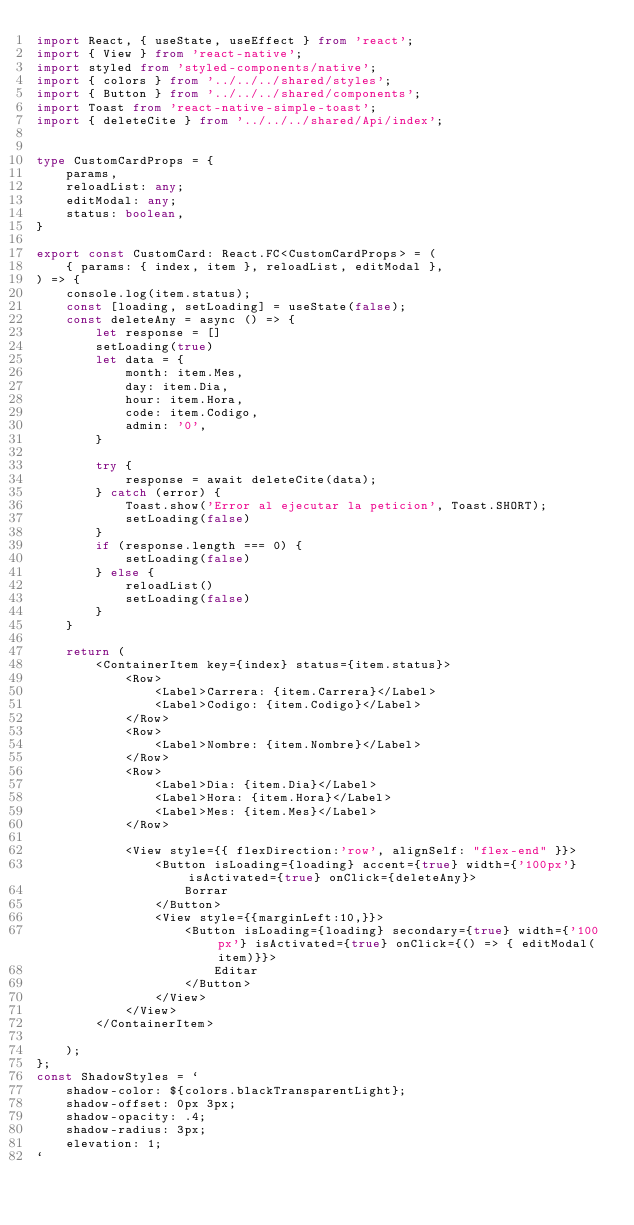Convert code to text. <code><loc_0><loc_0><loc_500><loc_500><_TypeScript_>import React, { useState, useEffect } from 'react';
import { View } from 'react-native';
import styled from 'styled-components/native';
import { colors } from '../../../shared/styles';
import { Button } from '../../../shared/components';
import Toast from 'react-native-simple-toast';
import { deleteCite } from '../../../shared/Api/index';


type CustomCardProps = {
    params,
    reloadList: any;
    editModal: any;
    status: boolean,
}

export const CustomCard: React.FC<CustomCardProps> = (
    { params: { index, item }, reloadList, editModal }, 
) => { 
    console.log(item.status);
    const [loading, setLoading] = useState(false);
    const deleteAny = async () => {
        let response = []
        setLoading(true)
        let data = {
            month: item.Mes,
            day: item.Dia,
            hour: item.Hora,
            code: item.Codigo,
            admin: '0',
        }
        
        try {
            response = await deleteCite(data);
        } catch (error) {
            Toast.show('Error al ejecutar la peticion', Toast.SHORT);
            setLoading(false)
        }
        if (response.length === 0) {
            setLoading(false)
        } else {
            reloadList()
            setLoading(false)
        }
    }
    
    return (
        <ContainerItem key={index} status={item.status}>
            <Row>
                <Label>Carrera: {item.Carrera}</Label>
                <Label>Codigo: {item.Codigo}</Label>
            </Row>
            <Row>
                <Label>Nombre: {item.Nombre}</Label>
            </Row>
            <Row>
                <Label>Dia: {item.Dia}</Label>
                <Label>Hora: {item.Hora}</Label>
                <Label>Mes: {item.Mes}</Label>
            </Row>

            <View style={{ flexDirection:'row', alignSelf: "flex-end" }}>
                <Button isLoading={loading} accent={true} width={'100px'} isActivated={true} onClick={deleteAny}>
                    Borrar
                </Button>
                <View style={{marginLeft:10,}}>
                    <Button isLoading={loading} secondary={true} width={'100px'} isActivated={true} onClick={() => { editModal(item)}}>
                        Editar
                    </Button>
                </View>
            </View>
        </ContainerItem>
                       
    );
};
const ShadowStyles = `
    shadow-color: ${colors.blackTransparentLight};
    shadow-offset: 0px 3px;
    shadow-opacity: .4;
    shadow-radius: 3px;
    elevation: 1;
`</code> 